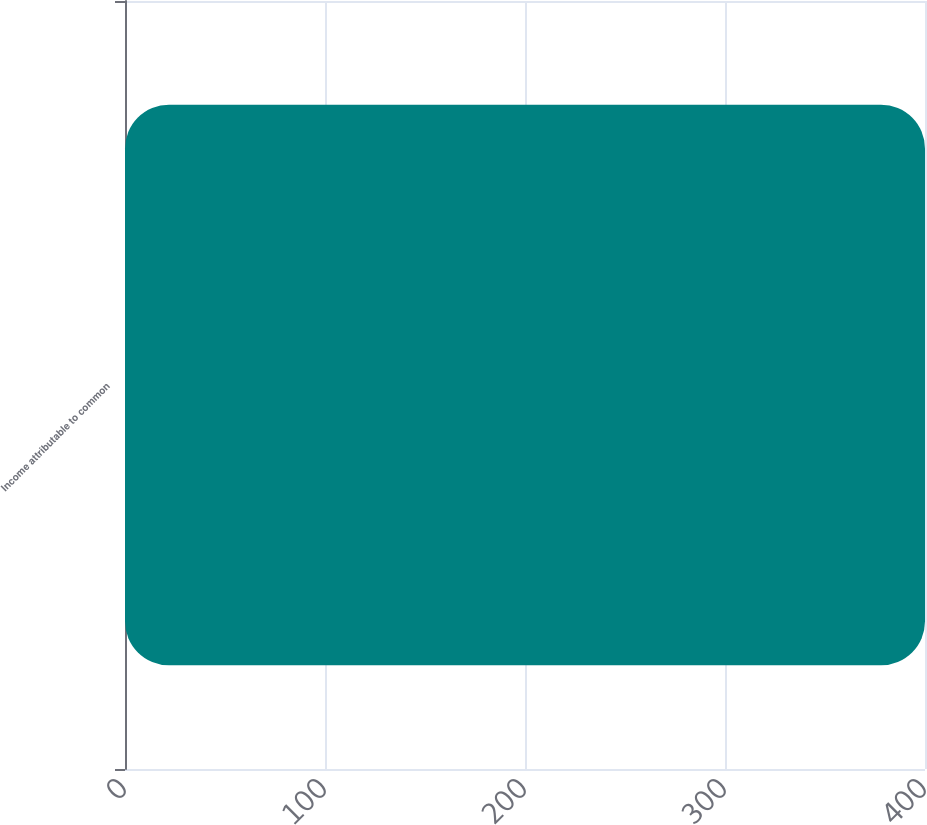Convert chart to OTSL. <chart><loc_0><loc_0><loc_500><loc_500><bar_chart><fcel>Income attributable to common<nl><fcel>400<nl></chart> 